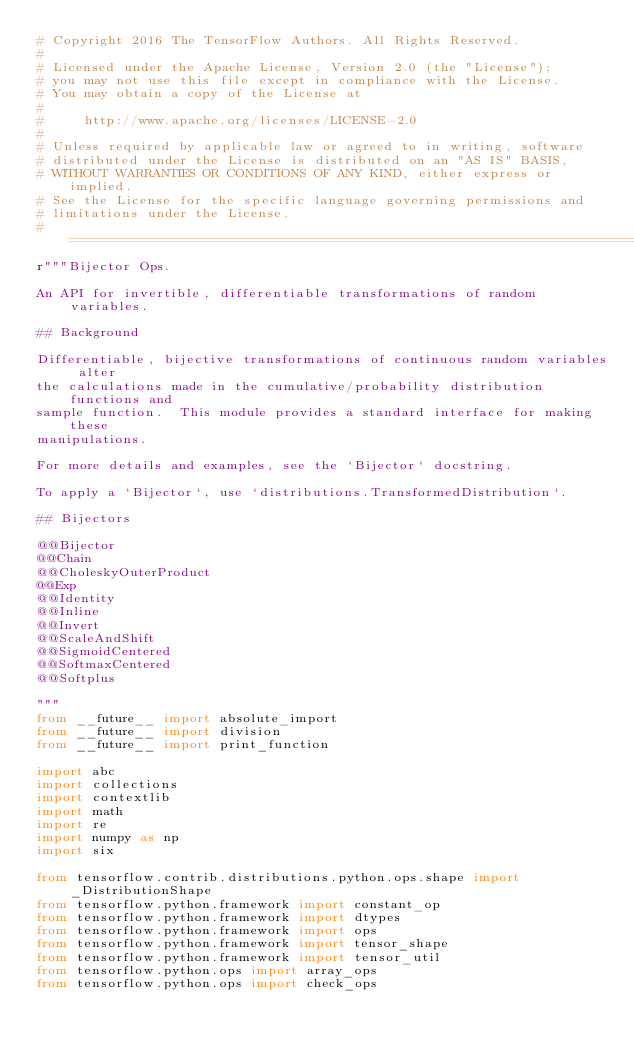Convert code to text. <code><loc_0><loc_0><loc_500><loc_500><_Python_># Copyright 2016 The TensorFlow Authors. All Rights Reserved.
#
# Licensed under the Apache License, Version 2.0 (the "License");
# you may not use this file except in compliance with the License.
# You may obtain a copy of the License at
#
#     http://www.apache.org/licenses/LICENSE-2.0
#
# Unless required by applicable law or agreed to in writing, software
# distributed under the License is distributed on an "AS IS" BASIS,
# WITHOUT WARRANTIES OR CONDITIONS OF ANY KIND, either express or implied.
# See the License for the specific language governing permissions and
# limitations under the License.
# ==============================================================================
r"""Bijector Ops.

An API for invertible, differentiable transformations of random variables.

## Background

Differentiable, bijective transformations of continuous random variables alter
the calculations made in the cumulative/probability distribution functions and
sample function.  This module provides a standard interface for making these
manipulations.

For more details and examples, see the `Bijector` docstring.

To apply a `Bijector`, use `distributions.TransformedDistribution`.

## Bijectors

@@Bijector
@@Chain
@@CholeskyOuterProduct
@@Exp
@@Identity
@@Inline
@@Invert
@@ScaleAndShift
@@SigmoidCentered
@@SoftmaxCentered
@@Softplus

"""
from __future__ import absolute_import
from __future__ import division
from __future__ import print_function

import abc
import collections
import contextlib
import math
import re
import numpy as np
import six

from tensorflow.contrib.distributions.python.ops.shape import _DistributionShape
from tensorflow.python.framework import constant_op
from tensorflow.python.framework import dtypes
from tensorflow.python.framework import ops
from tensorflow.python.framework import tensor_shape
from tensorflow.python.framework import tensor_util
from tensorflow.python.ops import array_ops
from tensorflow.python.ops import check_ops</code> 